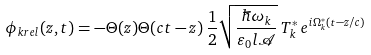<formula> <loc_0><loc_0><loc_500><loc_500>\phi _ { k r e l } ( z , t ) = - \Theta ( z ) \Theta ( c t - z ) \, { \frac { 1 } { 2 } } \sqrt { \frac { \hbar { \omega } _ { k } } { \varepsilon _ { 0 } l \mathcal { A } } } \, T _ { k } ^ { * } \, e ^ { i \Omega _ { k } ^ { * } ( t - z / c ) }</formula> 